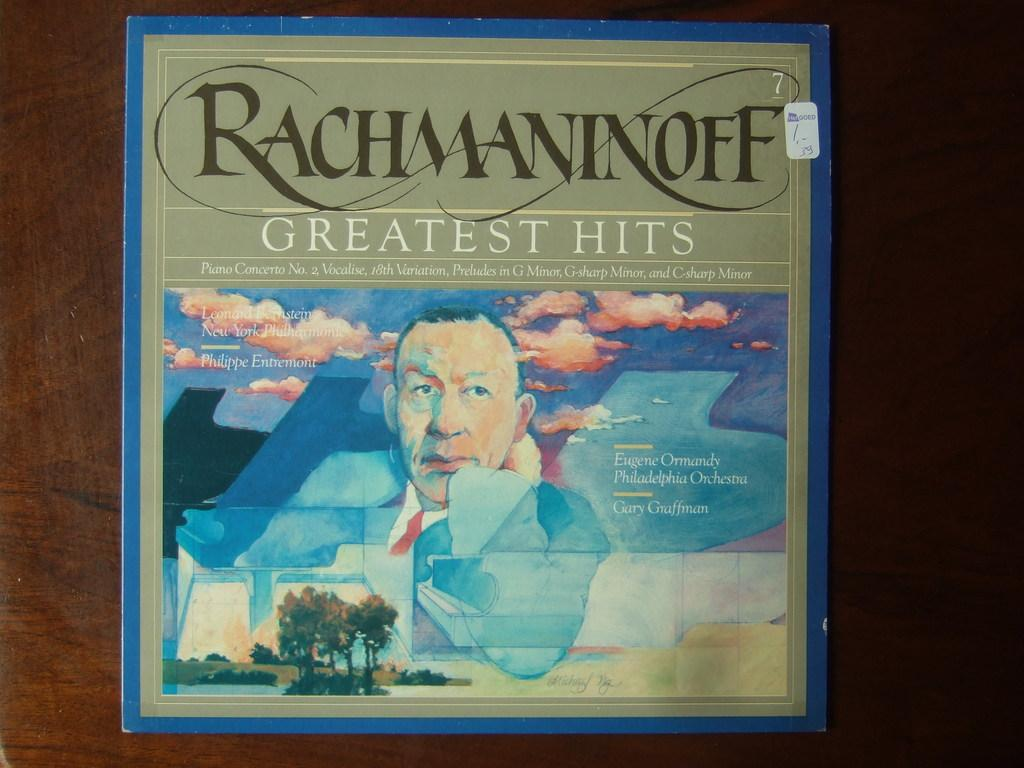<image>
Relay a brief, clear account of the picture shown. An album, Rachmaninoff Greatest Hits, on a dark wooden surface. 